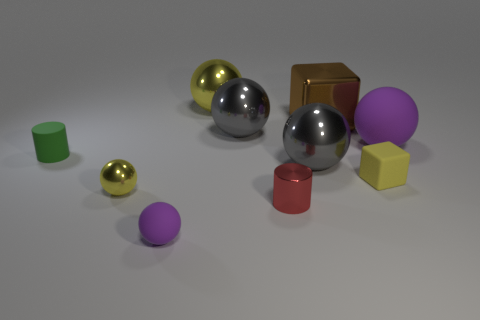Subtract 2 spheres. How many spheres are left? 4 Subtract all purple spheres. How many spheres are left? 4 Subtract all big rubber spheres. How many spheres are left? 5 Subtract all blue balls. Subtract all red cylinders. How many balls are left? 6 Subtract all cubes. How many objects are left? 8 Add 9 yellow cubes. How many yellow cubes exist? 10 Subtract 0 blue cubes. How many objects are left? 10 Subtract all large gray spheres. Subtract all gray balls. How many objects are left? 6 Add 1 small objects. How many small objects are left? 6 